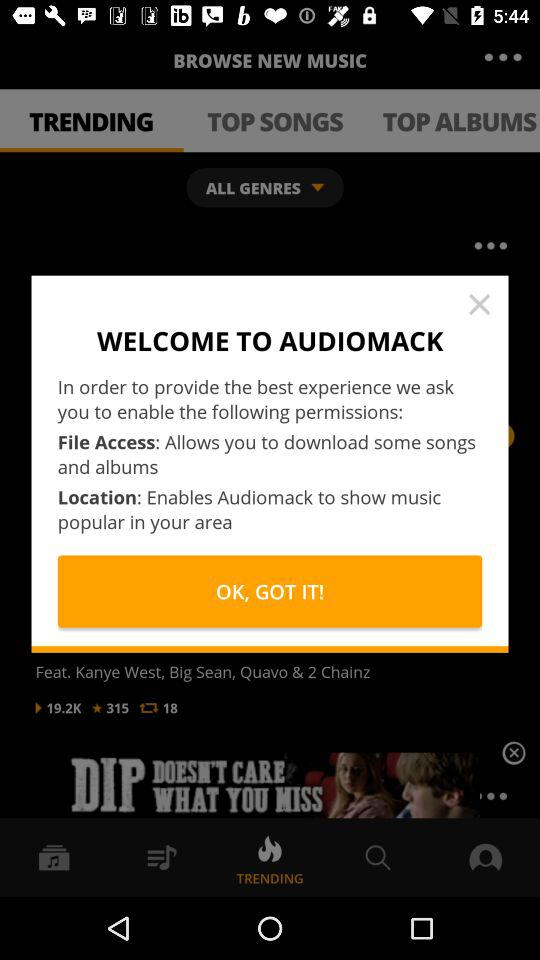How many permissions does the app request?
Answer the question using a single word or phrase. 2 